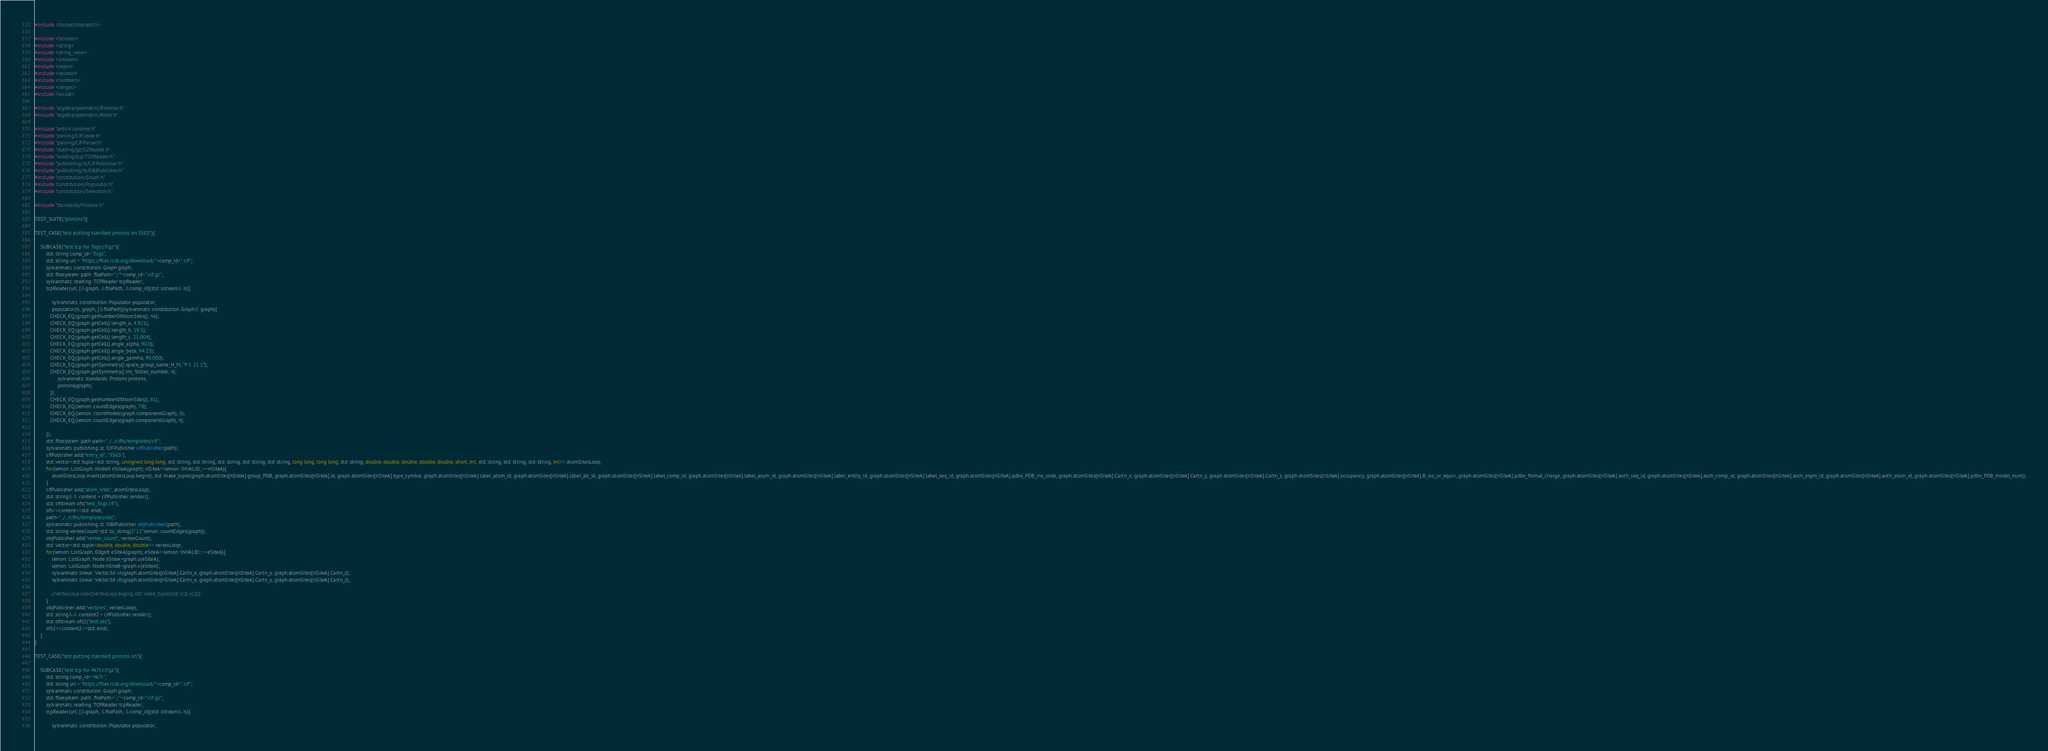Convert code to text. <code><loc_0><loc_0><loc_500><loc_500><_C++_>#include <doctest/doctest.h>

#include <fstream>
#include <string>
#include <string_view>
#include <sstream>
#include <regex>
#include <iterator>
#include <numbers>
#include <ranges>
#include <locale>

#include "algebra/geometric/Bivector.h"
#include "algebra/geometric/Rotor.h"

#include "antlr4-runtime.h"
#include "parsing/CIFLexer.h"
#include "parsing/CIFParser.h"
#include "reading/gz/GZReader.h"
#include "reading/tcp/TCPReader.h"
#include "publishing/st/CIFPublisher.h"
#include "publishing/st/OBJPublisher.h"
#include "constitution/Graph.h"
#include "constitution/Populator.h"
#include "constitution/Selection.h"

#include "standards/Protons.h"

TEST_SUITE("protons"){

TEST_CASE("test putting standard protons on 3SGS"){

    SUBCASE("test tcp for 3sgs.cif.gz"){
        std::string comp_id="3sgs";
        std::string url = "https://files.rcsb.org/download/"+comp_id+".cif";
        sylvanmats::constitution::Graph graph;
        std::filesystem::path  filePath="./"+comp_id+".cif.gz";
        sylvanmats::reading::TCPReader tcpReader;
        tcpReader(url, [&graph, &filePath, &comp_id](std::istream& is){

            sylvanmats::constitution::Populator populator;
            populator(is, graph, [&filePath](sylvanmats::constitution::Graph& graph){
           CHECK_EQ(graph.getNumberOfAtomSites(), 46);
           CHECK_EQ(graph.getCell().length_a, 4.821);
           CHECK_EQ(graph.getCell().length_b, 19.5);
           CHECK_EQ(graph.getCell().length_c, 21.004);
           CHECK_EQ(graph.getCell().angle_alpha, 90.0);
           CHECK_EQ(graph.getCell().angle_beta, 94.23);
           CHECK_EQ(graph.getCell().angle_gamma, 90.000);
           CHECK_EQ(graph.getSymmetry().space_group_name_H_M, "P 1 21 1");
           CHECK_EQ(graph.getSymmetry().Int_Tables_number, 4);
                sylvanmats::standards::Protons protons;
                protons(graph);
           });
           CHECK_EQ(graph.getNumberOfAtomSites(), 81);
           CHECK_EQ(lemon::countEdges(graph), 78);
           CHECK_EQ(lemon::countNodes(graph.componentGraph), 8);
           CHECK_EQ(lemon::countEdges(graph.componentGraph), 4);

        });
        std::filesystem::path path="../../cifio/templates/cif";
        sylvanmats::publishing::st::CIFPublisher cifPublisher(path);
        cifPublisher.add("entry_id", "3SGS");
        std::vector<std::tuple<std::string, unsigned long long, std::string, std::string, std::string, std::string, std::string, long long, long long, std::string, double, double, double, double, double, short, int, std::string, std::string, std::string, int>> atomSitesLoop;
        for(lemon::ListGraph::NodeIt nSiteA(graph); nSiteA!=lemon::INVALID; ++nSiteA){
            atomSitesLoop.insert(atomSitesLoop.begin(), std::make_tuple(graph.atomSites[nSiteA].group_PDB, graph.atomSites[nSiteA].id, graph.atomSites[nSiteA].type_symbol, graph.atomSites[nSiteA].label_atom_id, graph.atomSites[nSiteA].label_alt_id, graph.atomSites[nSiteA].label_comp_id, graph.atomSites[nSiteA].label_asym_id, graph.atomSites[nSiteA].label_entity_id, graph.atomSites[nSiteA].label_seq_id, graph.atomSites[nSiteA].pdbx_PDB_ins_code, graph.atomSites[nSiteA].Cartn_x, graph.atomSites[nSiteA].Cartn_y, graph.atomSites[nSiteA].Cartn_z, graph.atomSites[nSiteA].occupancy, graph.atomSites[nSiteA].B_iso_or_equiv, graph.atomSites[nSiteA].pdbx_formal_charge, graph.atomSites[nSiteA].auth_seq_id, graph.atomSites[nSiteA].auth_comp_id, graph.atomSites[nSiteA].auth_asym_id, graph.atomSites[nSiteA].auth_atom_id, graph.atomSites[nSiteA].pdbx_PDB_model_num));
        }
        cifPublisher.add("atom_sites", atomSitesLoop);
        std::string&& content = cifPublisher.render();
        std::ofstream ofs("test_3sgs.cif");
        ofs<<content<<std::endl;
        path="../../cifio/templates/obj";
        sylvanmats::publishing::st::OBJPublisher objPublisher(path);
        std::string vertexCount=std::to_string(2*12*lemon::countEdges(graph));
        objPublisher.add("vertex_count", vertexCount);
        std::vector<std::tuple<double, double, double>> vertexLoop;
        for(lemon::ListGraph::EdgeIt eSiteA(graph); eSiteA!=lemon::INVALID; ++eSiteA){
            lemon::ListGraph::Node nSiteA=graph.u(eSiteA);
            lemon::ListGraph::Node nSiteB=graph.v(eSiteA);
            sylvanmats::linear::Vector3d vA(graph.atomSites[nSiteA].Cartn_x, graph.atomSites[nSiteA].Cartn_y, graph.atomSites[nSiteA].Cartn_z);
            sylvanmats::linear::Vector3d vB(graph.atomSites[nSiteA].Cartn_x, graph.atomSites[nSiteA].Cartn_y, graph.atomSites[nSiteA].Cartn_z);
            
            //vertexLoop.insert(vertexLoop.begin(), std::make_tuple(v(0), v(1), v(2)));
        }
        objPublisher.add("vertices", vertexLoop);
        std::string&& content2 = cifPublisher.render();
        std::ofstream ofs2("test.obj");
        ofs2<<content2<<std::endl;
    }
}

TEST_CASE("test putting standard protons on"){

    SUBCASE("test tcp for 4k7t.cif.gz"){
        std::string comp_id="4k7t";
        std::string url = "https://files.rcsb.org/download/"+comp_id+".cif";
        sylvanmats::constitution::Graph graph;
        std::filesystem::path  filePath="./"+comp_id+".cif.gz";
        sylvanmats::reading::TCPReader tcpReader;
        tcpReader(url, [&graph, &filePath, &comp_id](std::istream& is){

            sylvanmats::constitution::Populator populator;</code> 